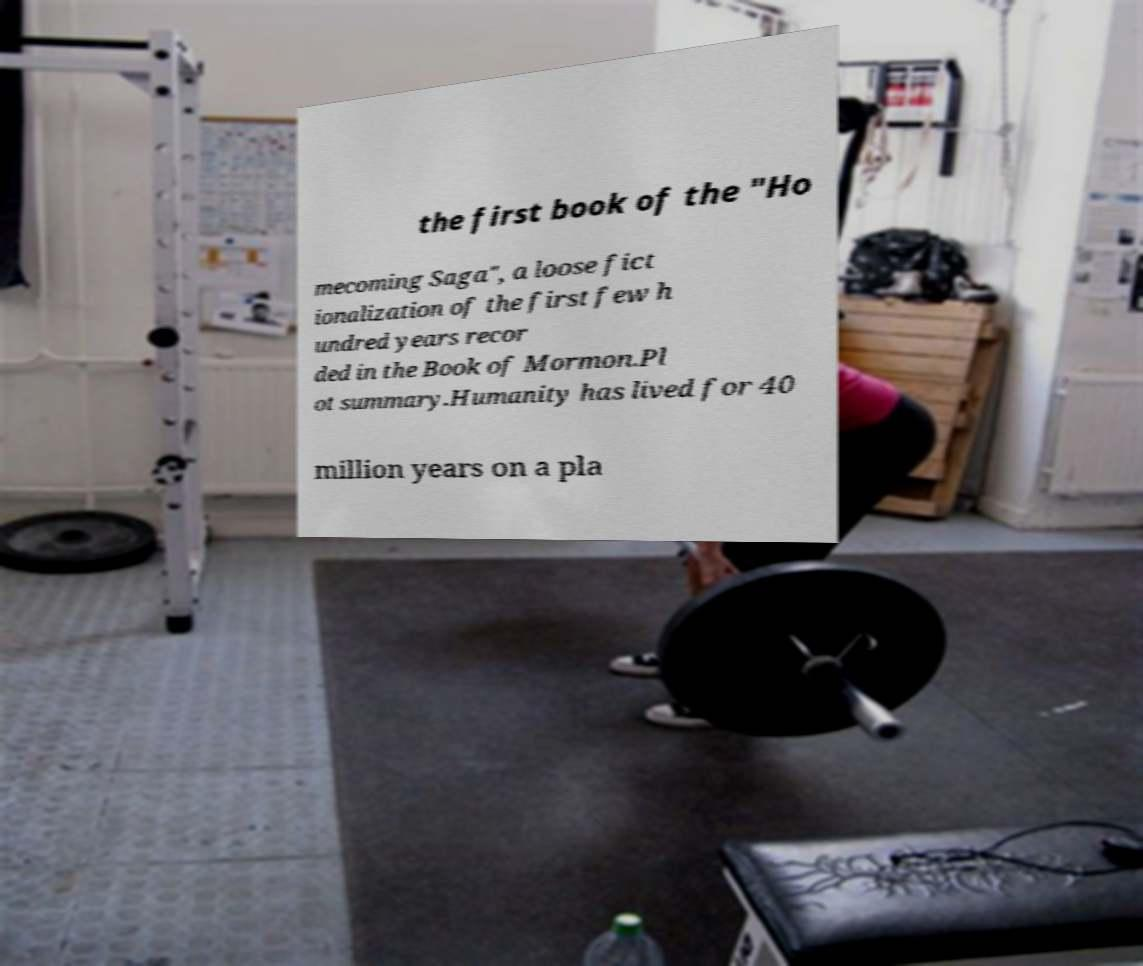Please identify and transcribe the text found in this image. the first book of the "Ho mecoming Saga", a loose fict ionalization of the first few h undred years recor ded in the Book of Mormon.Pl ot summary.Humanity has lived for 40 million years on a pla 